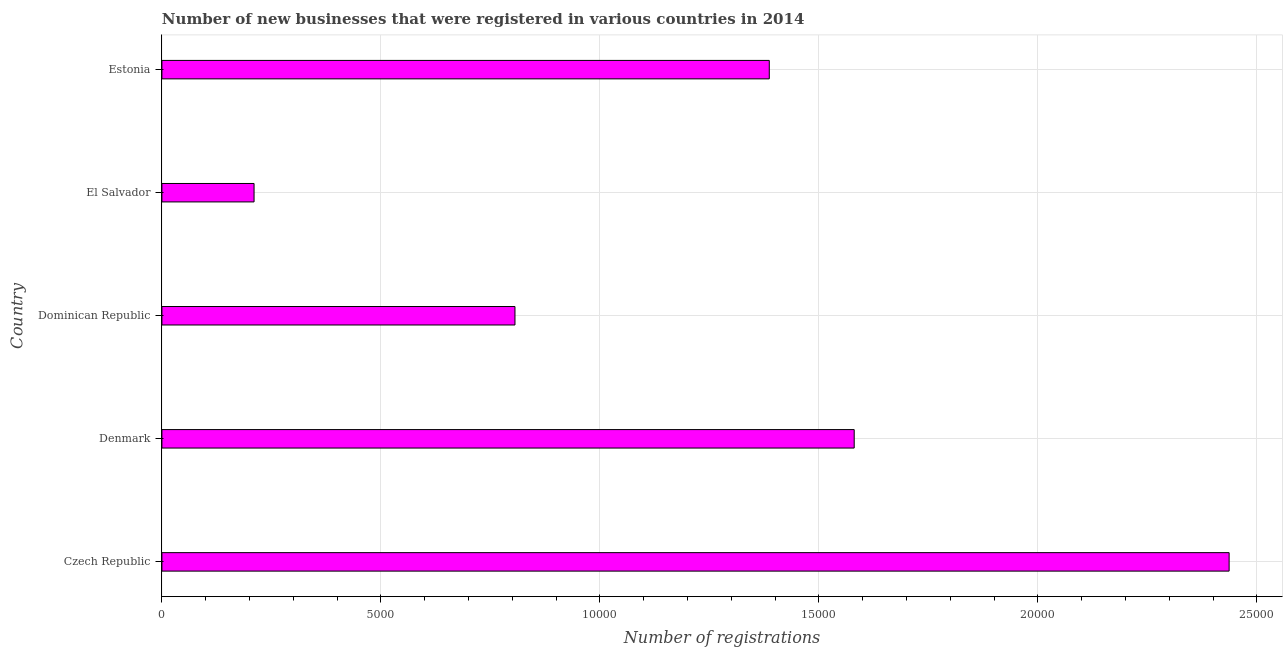Does the graph contain any zero values?
Ensure brevity in your answer.  No. Does the graph contain grids?
Give a very brief answer. Yes. What is the title of the graph?
Keep it short and to the point. Number of new businesses that were registered in various countries in 2014. What is the label or title of the X-axis?
Keep it short and to the point. Number of registrations. What is the number of new business registrations in Estonia?
Give a very brief answer. 1.39e+04. Across all countries, what is the maximum number of new business registrations?
Offer a terse response. 2.44e+04. Across all countries, what is the minimum number of new business registrations?
Ensure brevity in your answer.  2104. In which country was the number of new business registrations maximum?
Your answer should be very brief. Czech Republic. In which country was the number of new business registrations minimum?
Your answer should be very brief. El Salvador. What is the sum of the number of new business registrations?
Ensure brevity in your answer.  6.42e+04. What is the difference between the number of new business registrations in Dominican Republic and Estonia?
Offer a terse response. -5806. What is the average number of new business registrations per country?
Provide a succinct answer. 1.28e+04. What is the median number of new business registrations?
Provide a succinct answer. 1.39e+04. What is the ratio of the number of new business registrations in Dominican Republic to that in El Salvador?
Your response must be concise. 3.83. Is the number of new business registrations in Czech Republic less than that in Estonia?
Your answer should be compact. No. What is the difference between the highest and the second highest number of new business registrations?
Your response must be concise. 8560. Is the sum of the number of new business registrations in Czech Republic and Dominican Republic greater than the maximum number of new business registrations across all countries?
Your answer should be very brief. Yes. What is the difference between the highest and the lowest number of new business registrations?
Your answer should be compact. 2.23e+04. In how many countries, is the number of new business registrations greater than the average number of new business registrations taken over all countries?
Your response must be concise. 3. How many bars are there?
Offer a very short reply. 5. Are all the bars in the graph horizontal?
Keep it short and to the point. Yes. Are the values on the major ticks of X-axis written in scientific E-notation?
Offer a very short reply. No. What is the Number of registrations of Czech Republic?
Your answer should be very brief. 2.44e+04. What is the Number of registrations in Denmark?
Your response must be concise. 1.58e+04. What is the Number of registrations in Dominican Republic?
Ensure brevity in your answer.  8061. What is the Number of registrations in El Salvador?
Offer a very short reply. 2104. What is the Number of registrations in Estonia?
Ensure brevity in your answer.  1.39e+04. What is the difference between the Number of registrations in Czech Republic and Denmark?
Your answer should be very brief. 8560. What is the difference between the Number of registrations in Czech Republic and Dominican Republic?
Ensure brevity in your answer.  1.63e+04. What is the difference between the Number of registrations in Czech Republic and El Salvador?
Make the answer very short. 2.23e+04. What is the difference between the Number of registrations in Czech Republic and Estonia?
Your answer should be very brief. 1.05e+04. What is the difference between the Number of registrations in Denmark and Dominican Republic?
Your answer should be compact. 7745. What is the difference between the Number of registrations in Denmark and El Salvador?
Provide a succinct answer. 1.37e+04. What is the difference between the Number of registrations in Denmark and Estonia?
Make the answer very short. 1939. What is the difference between the Number of registrations in Dominican Republic and El Salvador?
Offer a terse response. 5957. What is the difference between the Number of registrations in Dominican Republic and Estonia?
Your response must be concise. -5806. What is the difference between the Number of registrations in El Salvador and Estonia?
Provide a short and direct response. -1.18e+04. What is the ratio of the Number of registrations in Czech Republic to that in Denmark?
Provide a short and direct response. 1.54. What is the ratio of the Number of registrations in Czech Republic to that in Dominican Republic?
Keep it short and to the point. 3.02. What is the ratio of the Number of registrations in Czech Republic to that in El Salvador?
Give a very brief answer. 11.58. What is the ratio of the Number of registrations in Czech Republic to that in Estonia?
Ensure brevity in your answer.  1.76. What is the ratio of the Number of registrations in Denmark to that in Dominican Republic?
Provide a short and direct response. 1.96. What is the ratio of the Number of registrations in Denmark to that in El Salvador?
Offer a terse response. 7.51. What is the ratio of the Number of registrations in Denmark to that in Estonia?
Offer a terse response. 1.14. What is the ratio of the Number of registrations in Dominican Republic to that in El Salvador?
Make the answer very short. 3.83. What is the ratio of the Number of registrations in Dominican Republic to that in Estonia?
Your response must be concise. 0.58. What is the ratio of the Number of registrations in El Salvador to that in Estonia?
Give a very brief answer. 0.15. 